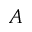<formula> <loc_0><loc_0><loc_500><loc_500>A</formula> 